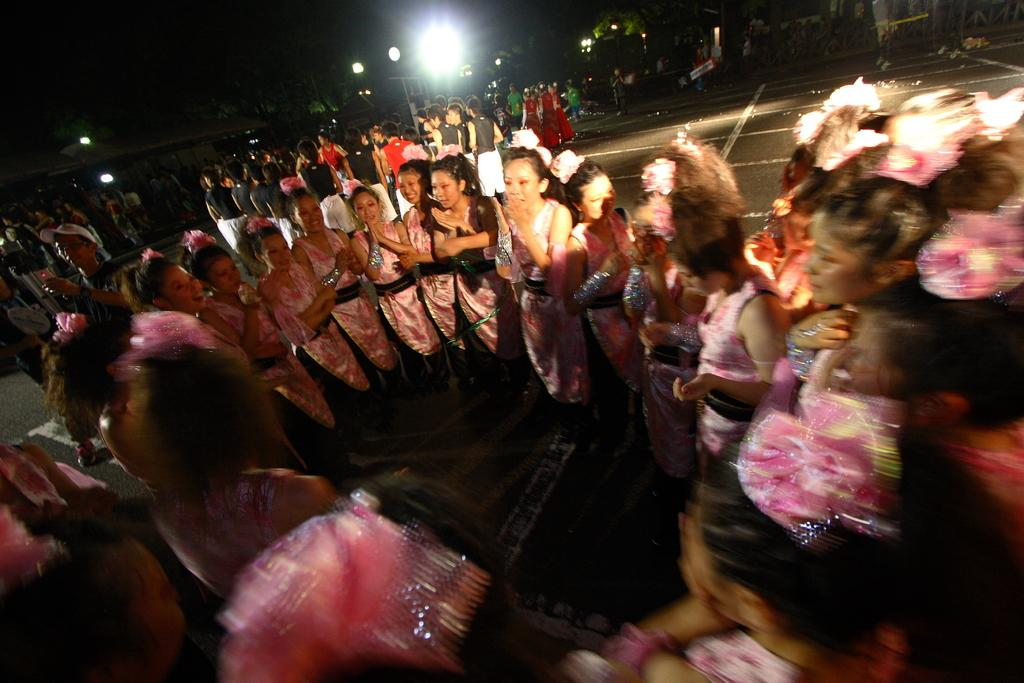What is happening in the image involving multiple people? There are groups of people in the image. Where are the people located in the image? The people are standing on the road. What are the people wearing in the image? The people are wearing different costumes. What objects can be seen in the image besides the people? There are lamps in the image. How would you describe the lighting in the image? The background of the image is dark. How much profit did the people make from their costumes in the image? There is no information about profit in the image; it only shows people wearing costumes and standing on the road. 